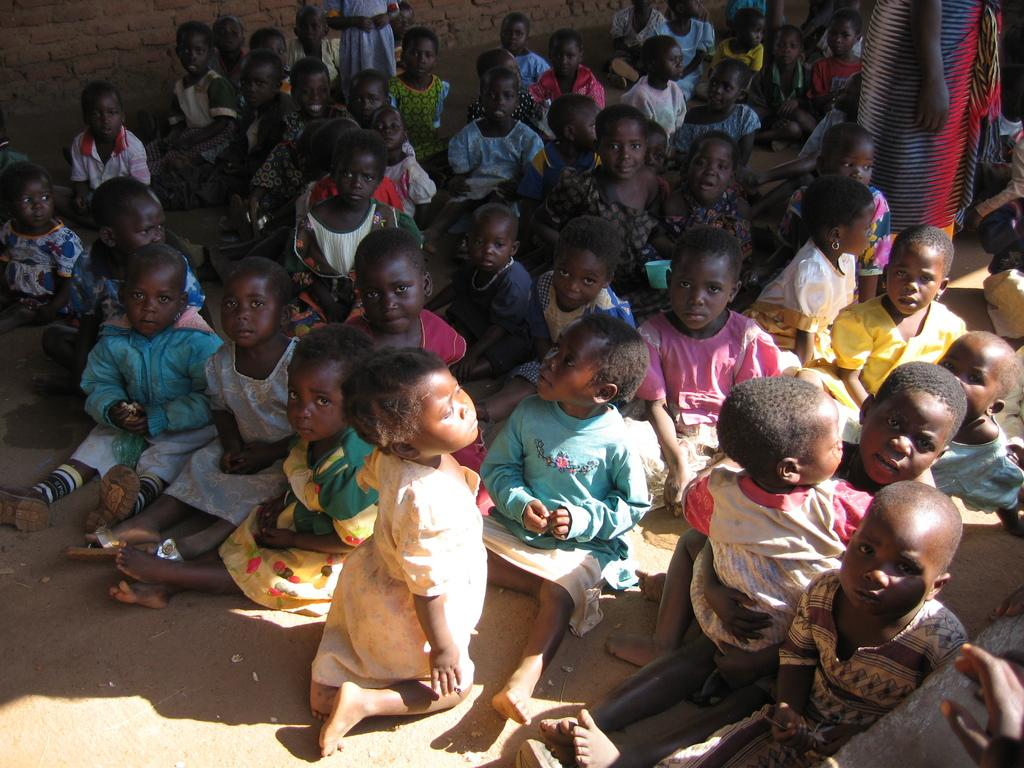What can be seen in the image? There are kids in the image. What are the kids wearing? The kids are wearing clothes. What is at the top of the image? There is a wall at the top of the image. Who else is in the image besides the kids? There is a person in the top right of the image. What is the person doing in the image? The person is standing. What is the person wearing in the image? The person is wearing clothes. What type of iron can be seen in the image? There is no iron present in the image. What kind of shop is visible in the image? There is no shop visible in the image. 